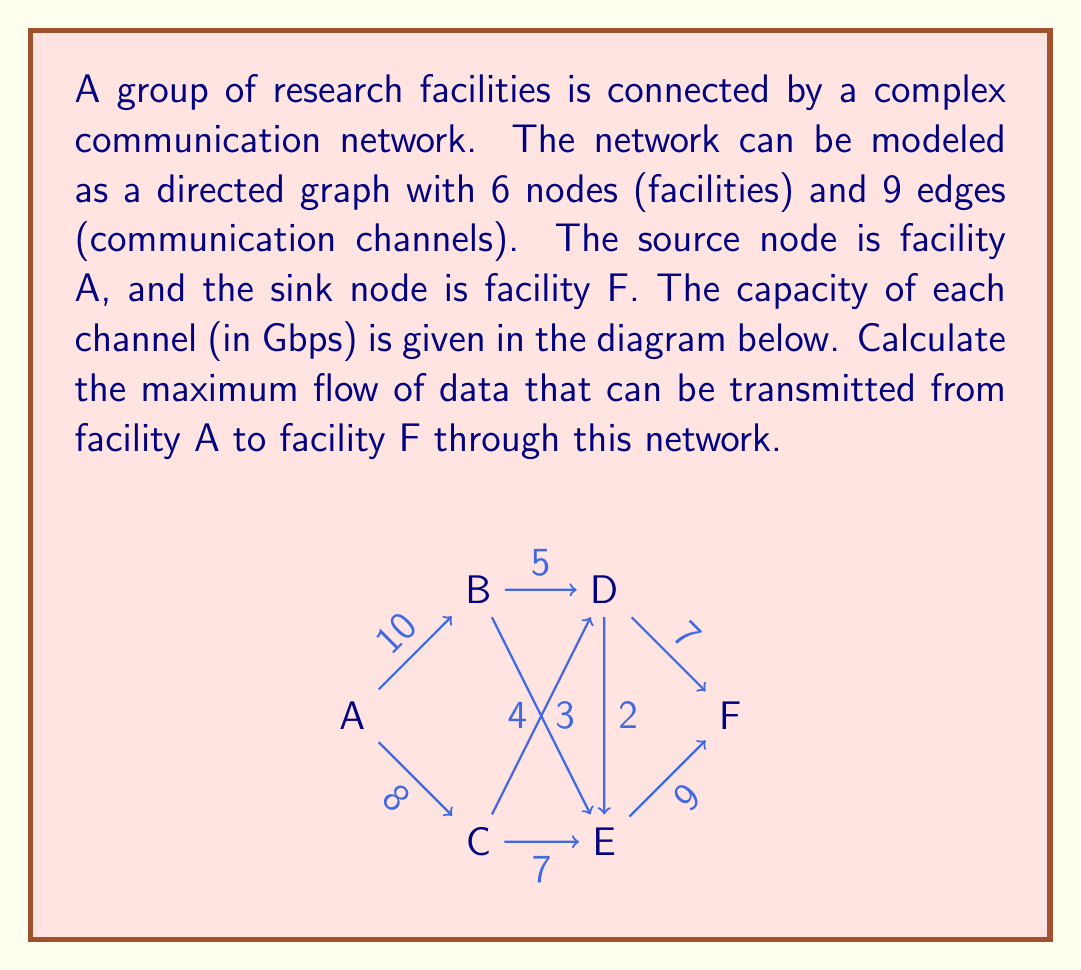What is the answer to this math problem? To solve this problem, we can use the Ford-Fulkerson algorithm or its improved version, the Edmonds-Karp algorithm, to find the maximum flow in the network.

Step 1: Initialize the flow to 0 for all edges.

Step 2: Find an augmenting path from source (A) to sink (F) using BFS (Breadth-First Search). 

Step 3: Augment the flow along this path by the minimum capacity of the edges in the path.

Step 4: Repeat steps 2 and 3 until no more augmenting paths can be found.

Let's apply these steps:

1st Iteration:
Path: A → B → D → F
Min capacity: min(10, 5, 7) = 5
Flow becomes: 5

2nd Iteration:
Path: A → C → E → F
Min capacity: min(8, 7, 9) = 7
Flow becomes: 5 + 7 = 12

3rd Iteration:
Path: A → B → E → F
Min capacity: min(5, 3, 9) = 3
Flow becomes: 12 + 3 = 15

4th Iteration:
Path: A → C → D → F
Min capacity: min(3, 4, 2) = 2
Flow becomes: 15 + 2 = 17

No more augmenting paths can be found.

The final flow configuration:
- A → B: 8/10
- A → C: 8/8
- B → D: 5/5
- B → E: 3/3
- C → D: 2/4
- C → E: 7/7
- D → F: 7/7
- E → F: 9/9
- D → E: 0/2

The maximum flow is the sum of flows out of the source (A) or into the sink (F), which is 17 Gbps.
Answer: The maximum flow of data that can be transmitted from facility A to facility F through this network is 17 Gbps. 